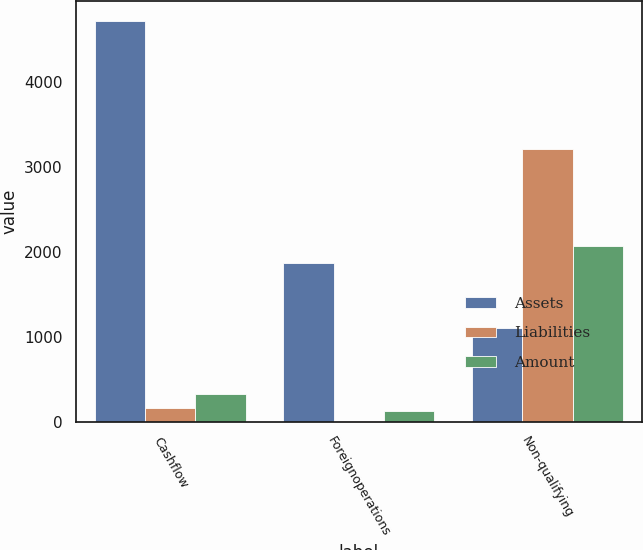Convert chart to OTSL. <chart><loc_0><loc_0><loc_500><loc_500><stacked_bar_chart><ecel><fcel>Cashflow<fcel>Foreignoperations<fcel>Non-qualifying<nl><fcel>Assets<fcel>4717<fcel>1872<fcel>1096.5<nl><fcel>Liabilities<fcel>161<fcel>11<fcel>3215<nl><fcel>Amount<fcel>321<fcel>119<fcel>2064<nl></chart> 